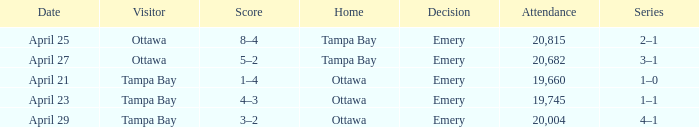What is the date of the game when attendance is more than 20,682? April 25. 